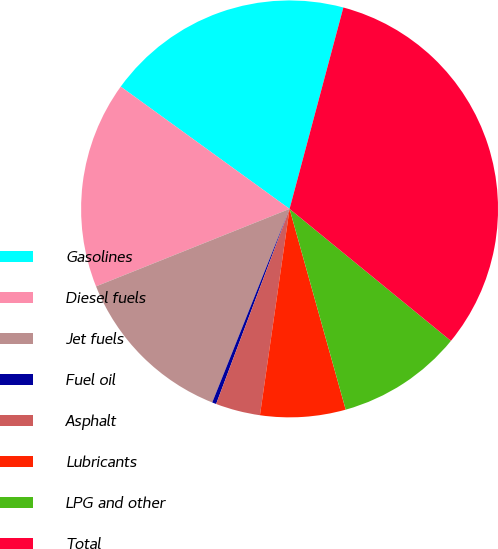Convert chart. <chart><loc_0><loc_0><loc_500><loc_500><pie_chart><fcel>Gasolines<fcel>Diesel fuels<fcel>Jet fuels<fcel>Fuel oil<fcel>Asphalt<fcel>Lubricants<fcel>LPG and other<fcel>Total<nl><fcel>19.18%<fcel>16.04%<fcel>12.89%<fcel>0.32%<fcel>3.46%<fcel>6.61%<fcel>9.75%<fcel>31.76%<nl></chart> 